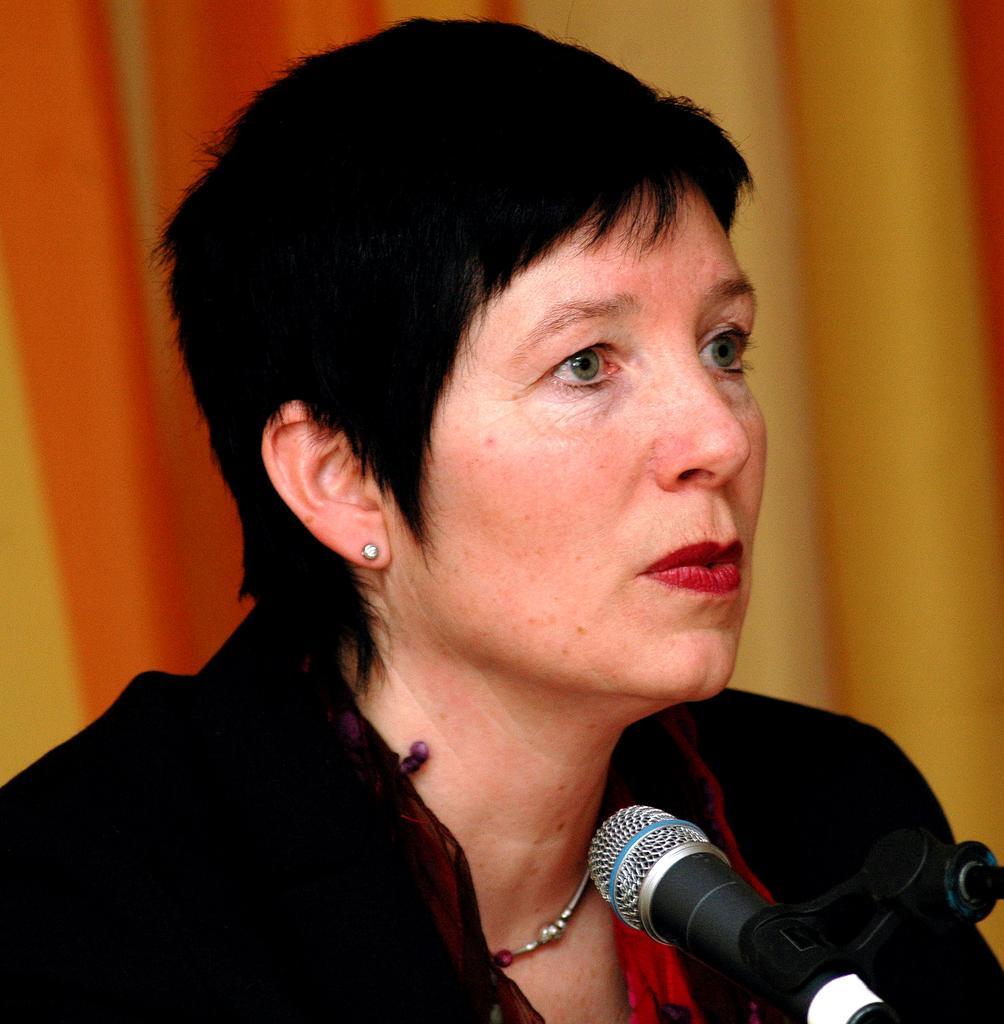In one or two sentences, can you explain what this image depicts? In this image we can see a lady, in front of her there is a mic, and the background is blurred. 